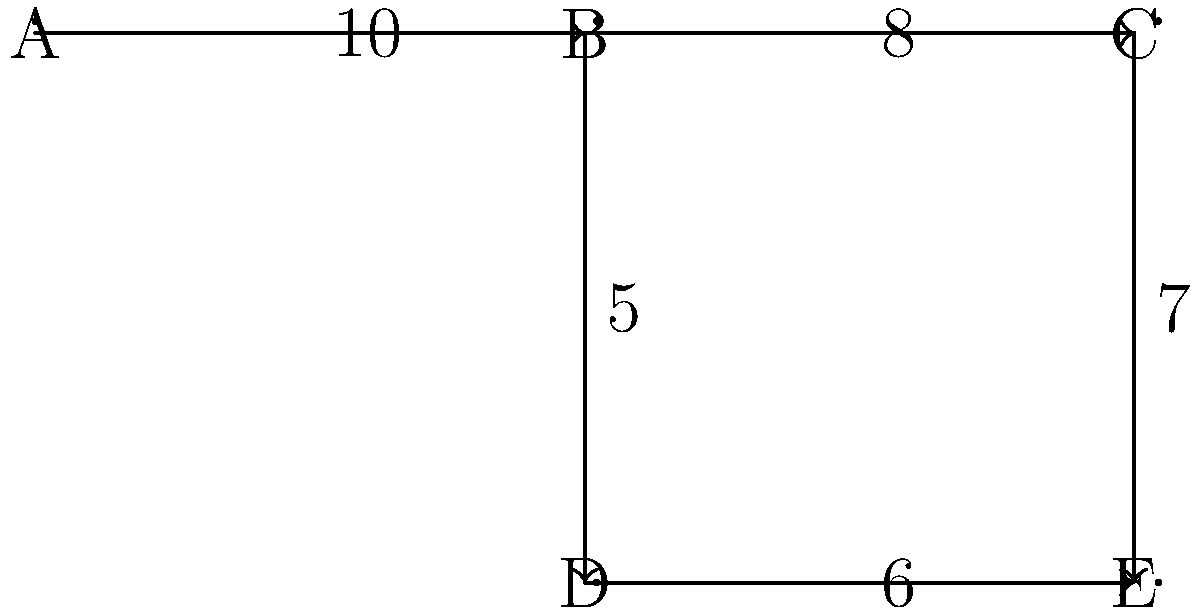Given the network flow diagram representing a data processing pipeline, where nodes represent processing stations and edge weights represent the maximum data throughput (in GB/hour) between stations, identify the bottleneck in the system that limits the overall data processing capacity. To identify the bottleneck in the data processing pipeline, we need to find the maximum flow from the source (node A) to the sink (node E). This can be done using the Ford-Fulkerson algorithm or by identifying the minimum cut in the graph.

Step 1: Identify all possible paths from A to E:
1. A → B → C → E
2. A → B → D → E

Step 2: Calculate the maximum flow for each path:
1. A → B → C → E: min(10, 8, 7) = 7 GB/hour
2. A → B → D → E: min(10, 5, 6) = 5 GB/hour

Step 3: Sum the maximum flows:
Total maximum flow = 7 + 5 = 12 GB/hour

Step 4: Identify the bottleneck:
The bottleneck is the edge or set of edges that, if removed, would disconnect the source from the sink and have a total capacity equal to the maximum flow.

In this case, we can see that the bottleneck is formed by edges B → C (8 GB/hour) and B → D (5 GB/hour), which together have a capacity of 13 GB/hour, close to our calculated maximum flow of 12 GB/hour.

The slight discrepancy is due to the limitation at C → E (7 GB/hour), which prevents full utilization of B → C.

Therefore, the main bottleneck limiting the overall data processing capacity is the edge B → D with a capacity of 5 GB/hour.
Answer: Edge B → D (5 GB/hour) 